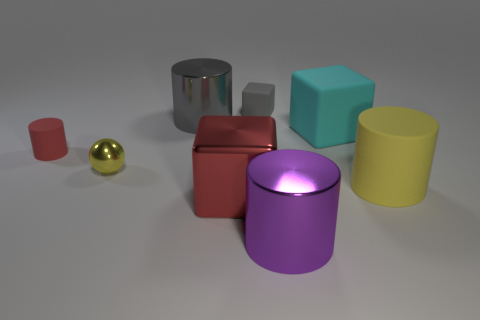There is a cylinder that is right of the large purple cylinder; what material is it?
Keep it short and to the point. Rubber. What is the size of the purple object that is the same shape as the big gray shiny object?
Offer a very short reply. Large. Are there fewer tiny yellow shiny things left of the yellow shiny sphere than gray shiny objects?
Offer a terse response. Yes. Is there a gray metallic object?
Offer a terse response. Yes. What is the color of the metal object that is the same shape as the large cyan matte object?
Your answer should be compact. Red. There is a small object that is behind the big cyan block; does it have the same color as the tiny matte cylinder?
Your response must be concise. No. Is the size of the red metal cube the same as the yellow cylinder?
Ensure brevity in your answer.  Yes. There is a tiny gray object that is made of the same material as the large cyan thing; what is its shape?
Offer a terse response. Cube. How many other objects are the same shape as the small yellow object?
Offer a very short reply. 0. The gray metal object that is left of the large shiny cylinder that is in front of the large block in front of the tiny red matte object is what shape?
Ensure brevity in your answer.  Cylinder. 